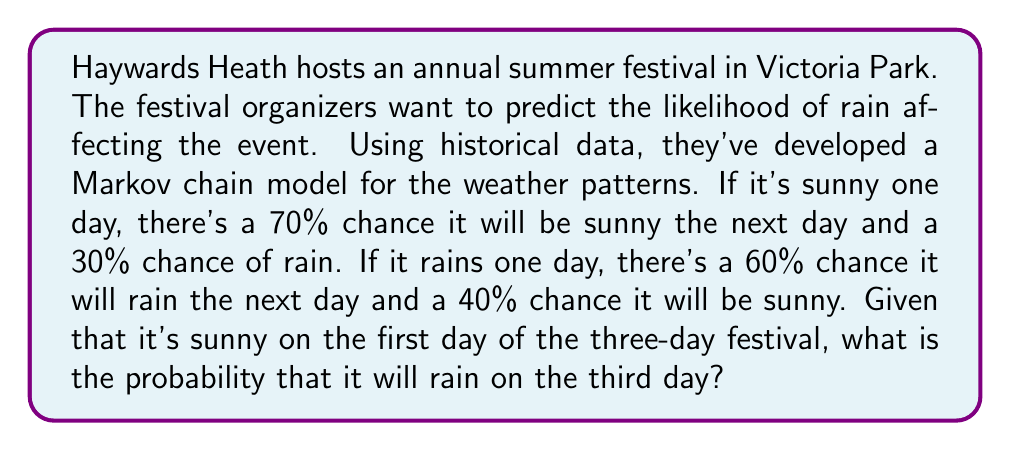Can you answer this question? Let's approach this step-by-step using Markov chains:

1) First, let's define our transition matrix P:

   $$P = \begin{bmatrix}
   0.7 & 0.3 \\
   0.4 & 0.6
   \end{bmatrix}$$

   Where the rows represent the current state (Sunny, Rainy) and the columns represent the next state.

2) We're interested in the probability of rain on the third day, given that it's sunny on the first day. This can be calculated by finding the probability distribution after two transitions.

3) Let's define our initial state vector:

   $$v_0 = \begin{bmatrix}
   1 \\
   0
   \end{bmatrix}$$

   This represents a 100% chance of sun on the first day.

4) To find the probability distribution after two days, we need to multiply our initial state by the transition matrix twice:

   $$v_2 = P^2 v_0$$

5) Let's calculate $P^2$:

   $$P^2 = \begin{bmatrix}
   0.7 & 0.3 \\
   0.4 & 0.6
   \end{bmatrix} \times \begin{bmatrix}
   0.7 & 0.3 \\
   0.4 & 0.6
   \end{bmatrix} = \begin{bmatrix}
   0.61 & 0.39 \\
   0.52 & 0.48
   \end{bmatrix}$$

6) Now, let's multiply this by our initial state vector:

   $$v_2 = \begin{bmatrix}
   0.61 & 0.39 \\
   0.52 & 0.48
   \end{bmatrix} \times \begin{bmatrix}
   1 \\
   0
   \end{bmatrix} = \begin{bmatrix}
   0.61 \\
   0.39
   \end{bmatrix}$$

7) The resulting vector shows the probability distribution for the third day. The second element (0.39) represents the probability of rain on the third day.

Therefore, the probability of rain on the third day of the festival is 0.39 or 39%.
Answer: 0.39 